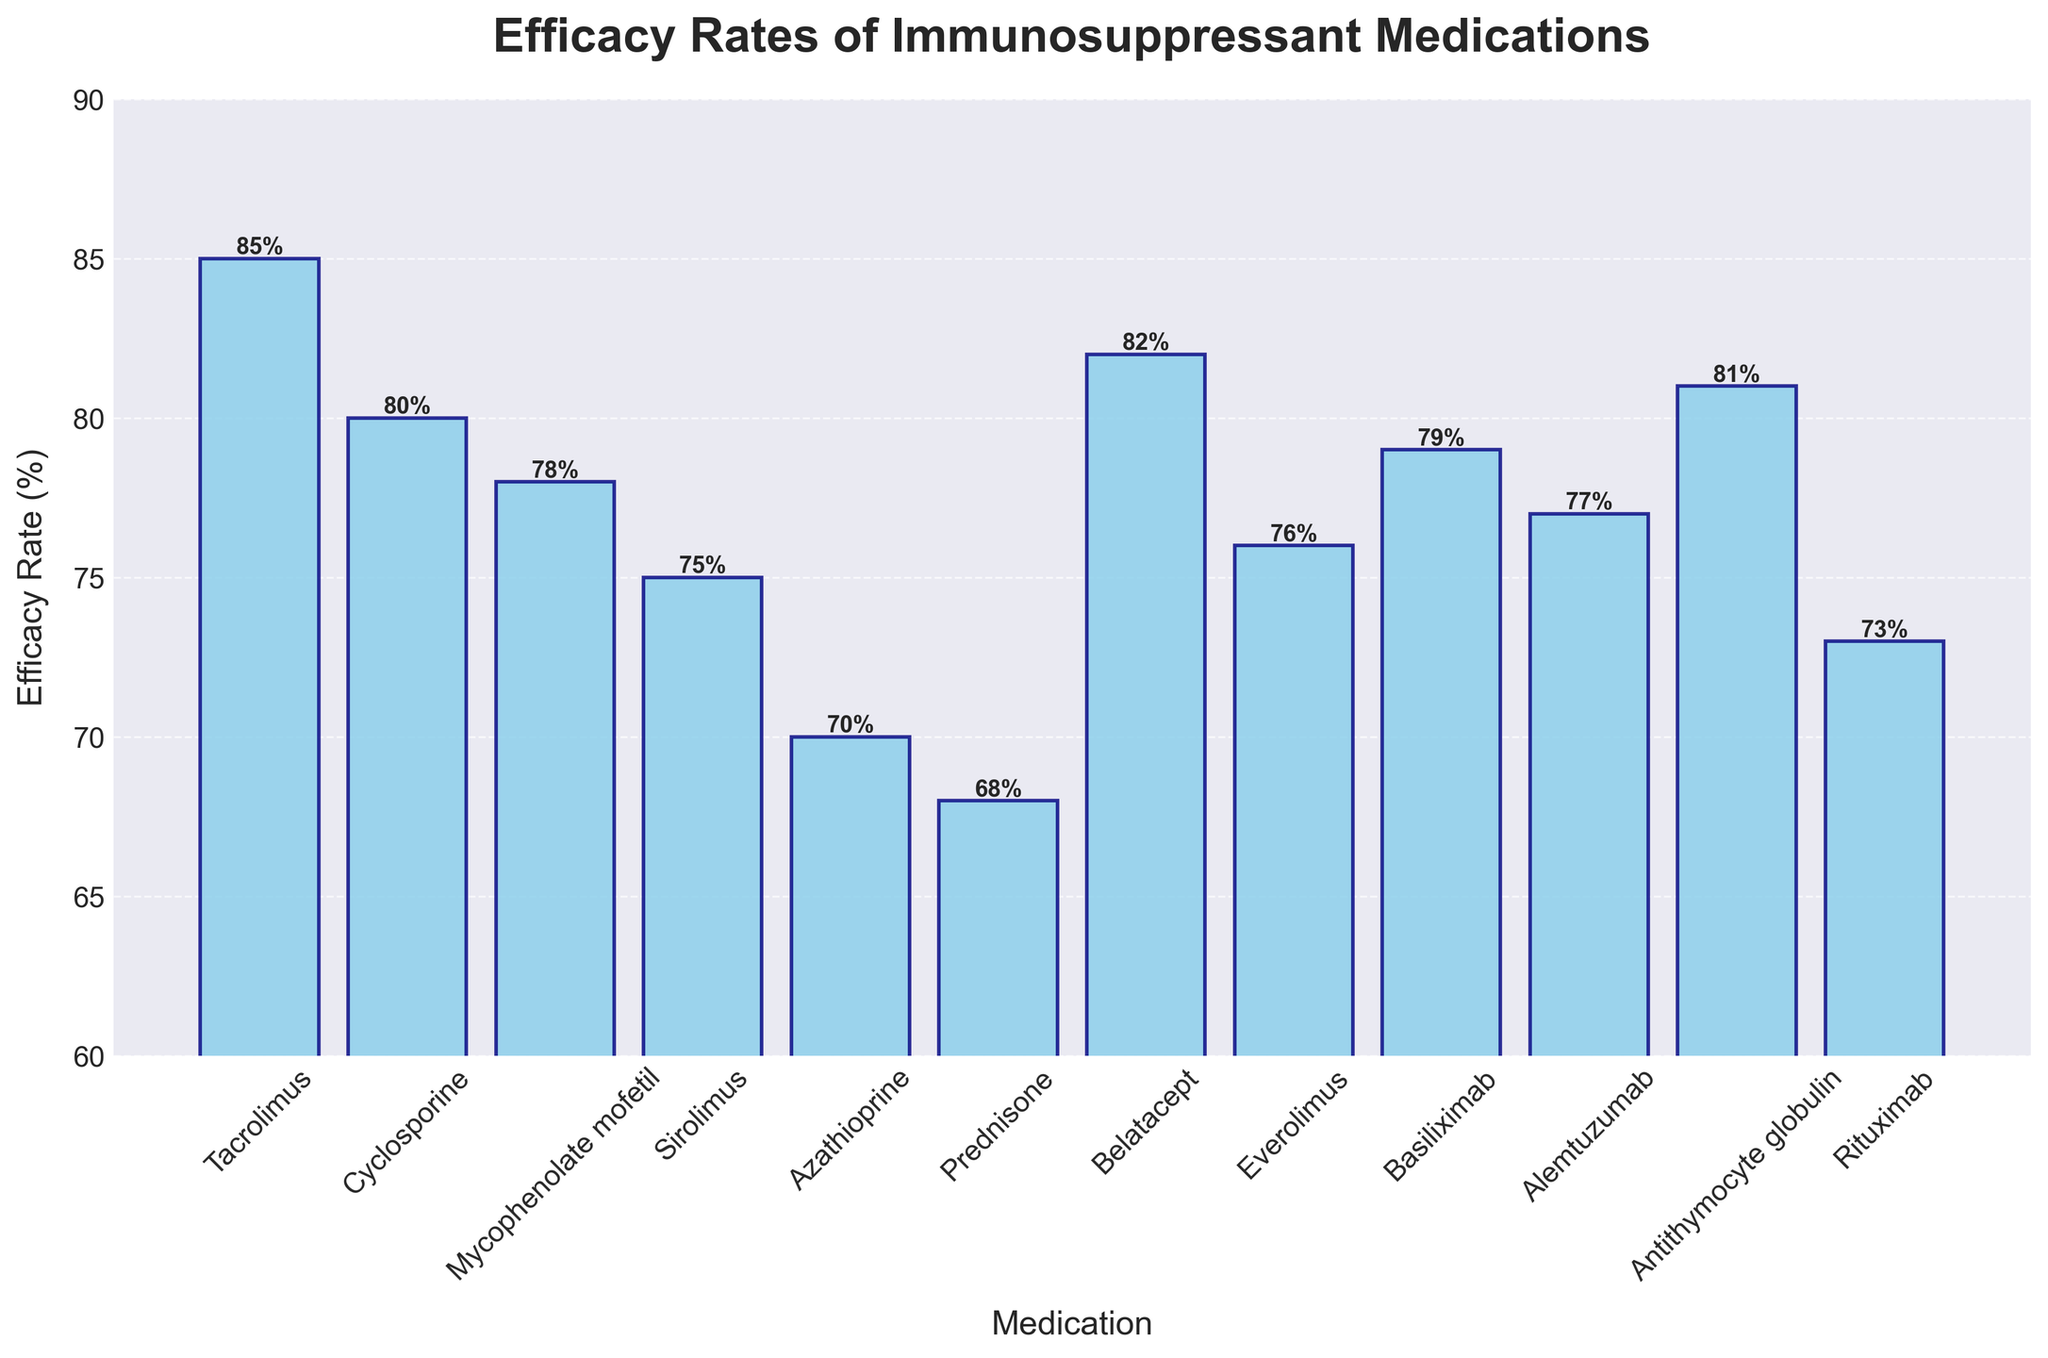Which medication has the highest efficacy rate? By observing the height of the bars, Tacrolimus has the highest efficacy rate.
Answer: Tacrolimus Which medication has a lower efficacy rate, Sirolimus or Belatacept? Comparing the heights of the bars, Sirolimus has a lower efficacy rate than Belatacept.
Answer: Sirolimus What is the efficacy rate range displayed in the figure? The lowest efficacy rate is 68% (Prednisone), and the highest is 85% (Tacrolimus). The range is from 68% to 85%.
Answer: 68% to 85% How many medications have an efficacy rate higher than 80%? Tacrolimus (85%), Belatacept (82%), Antithymocyte globulin (81%), Cyclosporine (80%) have rates above 80%.
Answer: 4 What is the average efficacy rate of the medications from Tacrolimus, Cyclosporine, and Prednisone? To find the average: (85 + 80 + 68) / 3 = 233 / 3 = 77.67%.
Answer: 77.67% Which two medications have efficacy rates closest to 75%? By looking at the bars, Everolimus (76%) and Alemtuzumab (77%) have rates closest to 75%.
Answer: Everolimus and Alemtuzumab Are there more medications with efficacy rates greater than or less than 75%? There are 7 medications above 75% (Tacrolimus, Cyclosporine, Belatacept, Antithymocyte globulin, Basiliximab, Alemtuzumab, Everolimus) and 5 below or equal to 75% (others). Therefore, more medications have effectiveness rates above 75%.
Answer: Greater than 75% What is the sum of the efficacy rates of the three medications with the lowest efficacy? Prednisone (68%), Azathioprine (70%), and Rituximab (73%) are the lowest. Sum: 68 + 70 + 73 = 211%.
Answer: 211% Calculate the difference in efficacy rate between Tacrolimus and Mycophenolate mofetil. The efficacy rate of Tacrolimus is 85% and Mycophenolate mofetil is 78%. Difference: 85 - 78 = 7%.
Answer: 7% Which medications have efficacy rates exactly divisible by 10? From the chart, Cyclosporine (80%) and Azathioprine (70%) have rates divisible by 10.
Answer: Cyclosporine and Azathioprine 